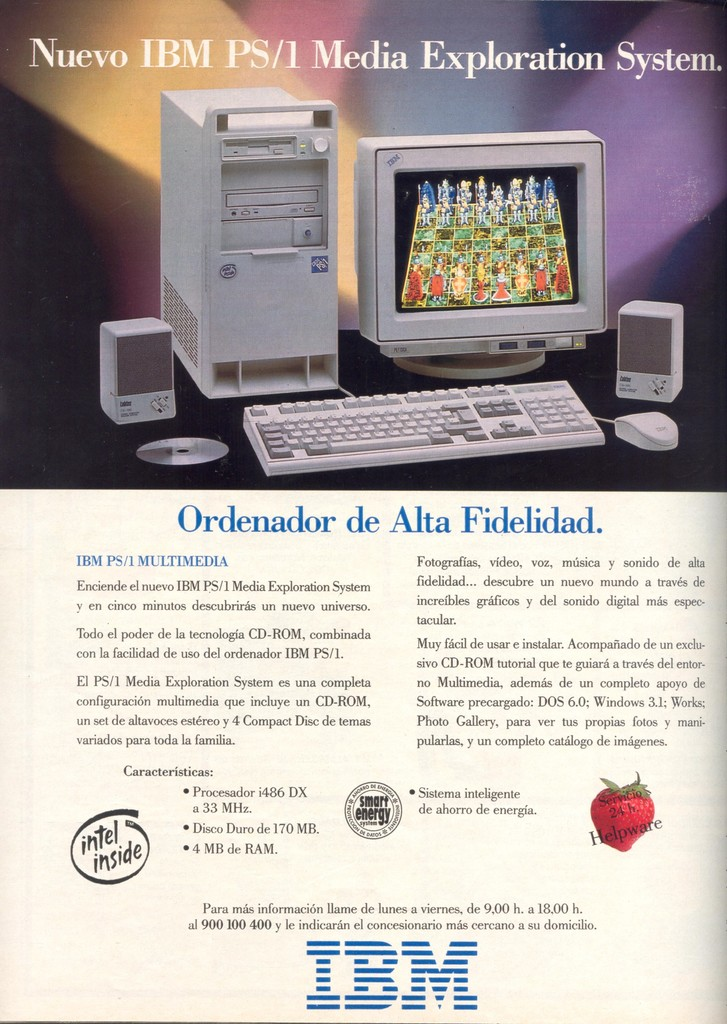What specific details explain how this system caters to multimedia needs? The IBM PS/1 Media Exploration System is engineered for multimedia use, as indicated by several key features detailed in the advertisement. The presence of a CD-ROM drive is crucial, enabling users to access a broad range of media, including software, music, and video. The system's processor, a 486 DX at 33 MHz, and 4 MB of RAM are suitable for handling the demands of early multimedia software. Additionally, the advertised inclusion of specific multimedia-oriented software like a Photo Gallery for image manipulation and Works 3.1 for office tasks highlights the system's utility in managing and creating multimedia content. How do the design and visual elements of the ad contribute to its appeal? The advertisement employs a visually striking design to captivate potential buyers. It prominently displays the computer system along with open doors, symbolizing an invitation to explore new technological realms. The vibrant chess graphics on the monitor not only showcase the system's graphical capabilities but also metaphorically suggest strategic thinking and intelligence. The layout is clean and well-organized, making the technical specifications easily readable and understandable. The overall aesthetic is modern and professional, aligning with the advanced technological image IBM wishes to project. 